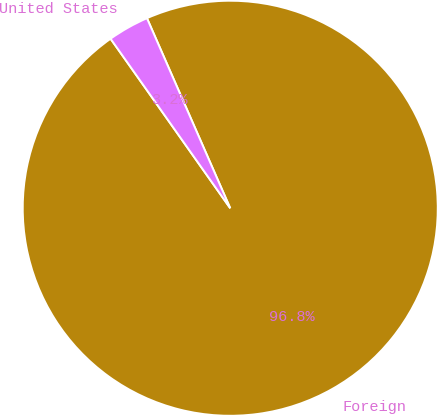Convert chart to OTSL. <chart><loc_0><loc_0><loc_500><loc_500><pie_chart><fcel>Foreign<fcel>United States<nl><fcel>96.79%<fcel>3.21%<nl></chart> 